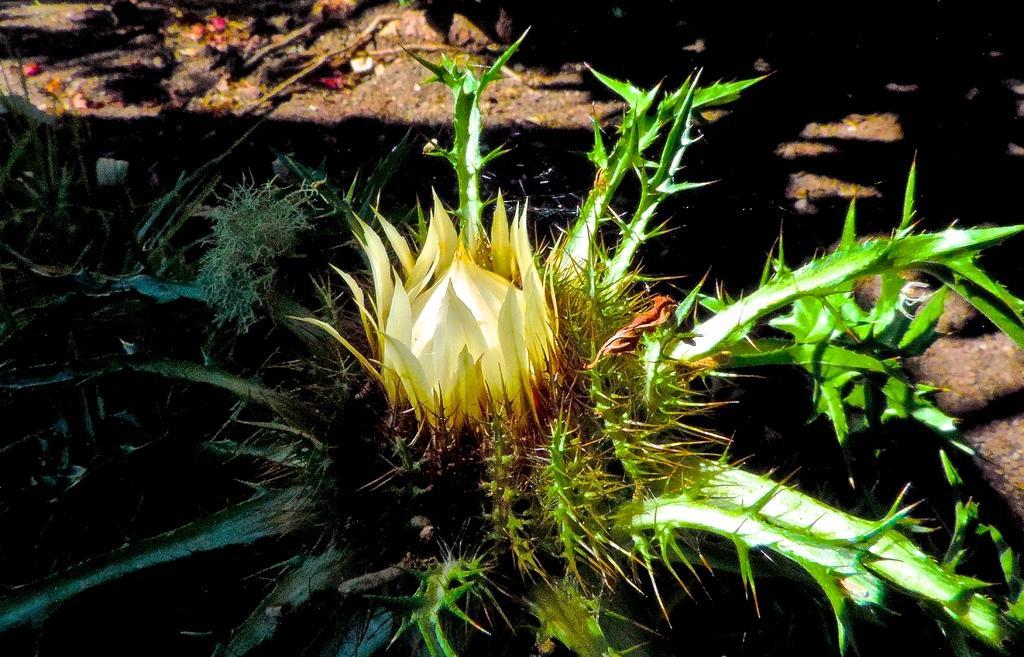Describe this image in one or two sentences. In this picture we can see a plant in the front, there is a blurry background. 